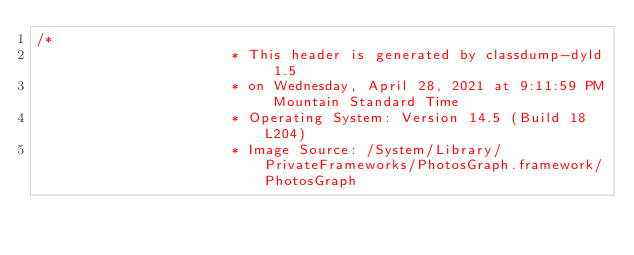<code> <loc_0><loc_0><loc_500><loc_500><_C_>/*
                       * This header is generated by classdump-dyld 1.5
                       * on Wednesday, April 28, 2021 at 9:11:59 PM Mountain Standard Time
                       * Operating System: Version 14.5 (Build 18L204)
                       * Image Source: /System/Library/PrivateFrameworks/PhotosGraph.framework/PhotosGraph</code> 